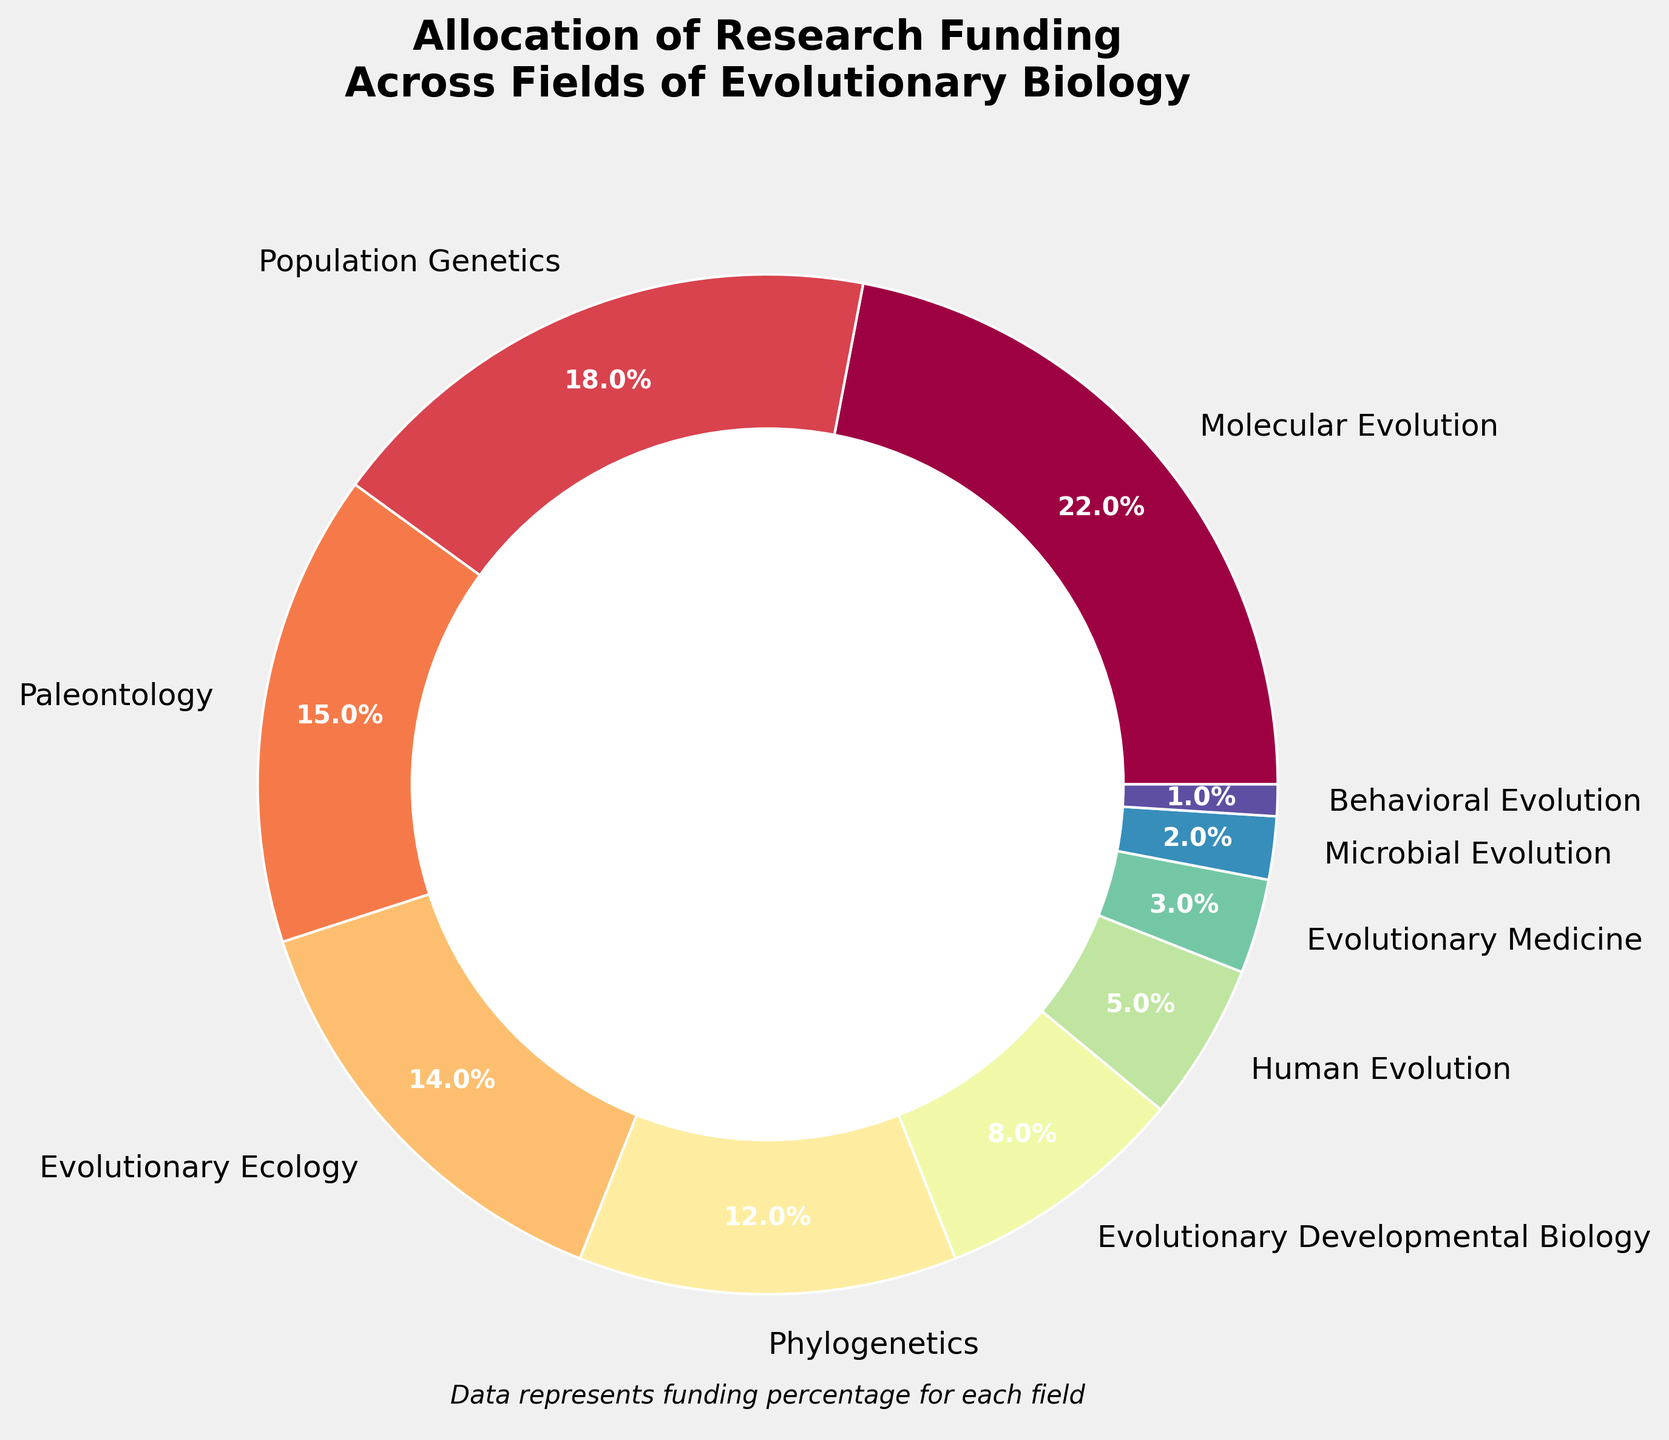What is the field with the highest percentage of research funding? By inspecting the pie chart, the segment with the highest percentage is labeled "Molecular Evolution" with 22%.
Answer: Molecular Evolution Compare the funding percentages for Population Genetics and Evolutionary Medicine. Which one is higher, and by how much? Population Genetics receives 18% and Evolutionary Medicine receives 3%. To find the difference, subtract 3% from 18%: 18% - 3% = 15%. So, Population Genetics has a higher funding percentage by 15%.
Answer: Population Genetics, 15% What is the combined funding percentage for Paleontology and Human Evolution? The funding percentage for Paleontology is 15% and for Human Evolution is 5%. Add these values together: 15% + 5% = 20%.
Answer: 20% Which field has the smallest allocation of research funding? By checking the slices, the smallest percentage is for Behavioral Evolution, which is 1%.
Answer: Behavioral Evolution Is the funding for Evolutionary Medicine higher than the funding for Microbial Evolution? The pie chart shows Evolutionary Medicine has 3% while Microbial Evolution has 2%. Since 3% is greater than 2%, Evolutionary Medicine has higher funding.
Answer: Yes Is the total funding for Evolutionary Developmental Biology and Human Evolution more than 10%? Evolutionary Developmental Biology has 8% and Human Evolution has 5%. Add these values together: 8% + 5% = 13%. Since 13% is greater than 10%, the combined funding exceeds 10%.
Answer: Yes What percentage of funding is allocated to fields other than Molecular Evolution, Population Genetics, and Paleontology? Add the funding percentages of Molecular Evolution (22%), Population Genetics (18%), and Paleontology (15%): 22% + 18% + 15% = 55%. Subtract this sum from 100% to find the funding for the other fields: 100% - 55% = 45%.
Answer: 45% Which fields together receive an equal or greater amount of funding than Molecular Evolution? Molecular Evolution receives 22%. Looking at combinations: Evolutionary Ecology (14%) + Phylogenetics (12%) = 26%, which is greater than 22%. Other combinations are also possible, but this example fulfills the condition.
Answer: Evolutionary Ecology and Phylogenetics Are the fields represented with percentages in single digits more than those in double digits? Fields with single-digit percentages: Evolutionary Developmental Biology (8%), Human Evolution (5%), Evolutionary Medicine (3%), Microbial Evolution (2%), and Behavioral Evolution (1%)—totaling 5 fields. Fields with double-digit percentages: Molecular Evolution (22%), Population Genetics (18%), Paleontology (15%), Evolutionary Ecology (14%), and Phylogenetics (12%)—also totaling 5 fields.
Answer: No 